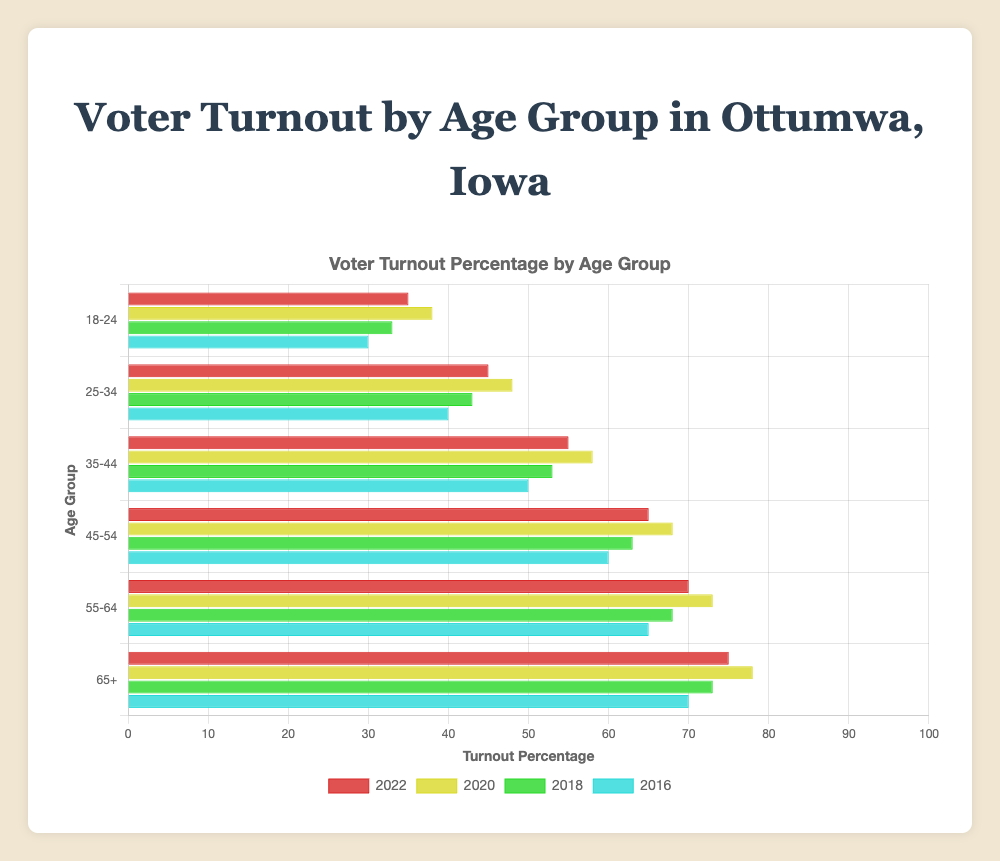What is the turnout percentage for the 18-24 age group in 2020? Look at the horizontal bar for the 18-24 age group in the year 2020, it has a turnout percentage of 38.
Answer: 38 Which age group had the highest turnout percentage in 2018? Identify the tallest horizontal bar for the year 2018. The 65+ age group had the highest turnout percentage, at 73.
Answer: 65+ How did the turnout percentage of the 25-34 age group change from 2016 to 2022? Compare the horizontal bars for the 25-34 age group in 2016 and 2022. The turnout increased from 40 in 2016 to 45 in 2022.
Answer: Increased by 5 Between which two age groups is the turnout difference the largest in 2022? Look at the horizontal bars for all age groups in 2022 and calculate the differences. The biggest difference is between the 18-24 (35) and 65+ (75) age groups, which is 40.
Answer: 18-24 and 65+ What is the average voter turnout percentage for all age groups in 2022? Add the turnout percentages for all age groups in 2022 (35, 45, 55, 65, 70, 75) and divide by the number of age groups (6). The sum is 345, so the average is 345 / 6 = 57.5.
Answer: 57.5 Did the 45-54 age group's turnout percentage consistently increase from 2016 to 2022? Examine the 45-54 age group's horizontal bars for each year. The turnout percentage is 60 in 2016, 63 in 2018, 68 in 2020, and 65 in 2022. The percentage decreased from 2020 to 2022.
Answer: No Which year had the overall lowest turnout percentage for the 55-64 age group? Check the horizontal bars for the 55-64 age group in all years. The lowest turnout percentage is 65 in 2016.
Answer: 2016 Is there a noticeable change in turnout for the 35-44 age group between 2016 and 2020? Compare the bar lengths for the 35-44 age group in 2016 (50) and 2020 (58). The change is an increase of 8 percentage points.
Answer: Yes Considering the 65+ age group, which year showed the highest participation rate? Identify the tallest bar for the 65+ age group. The highest turnout percentage is 78 in 2020.
Answer: 2020 